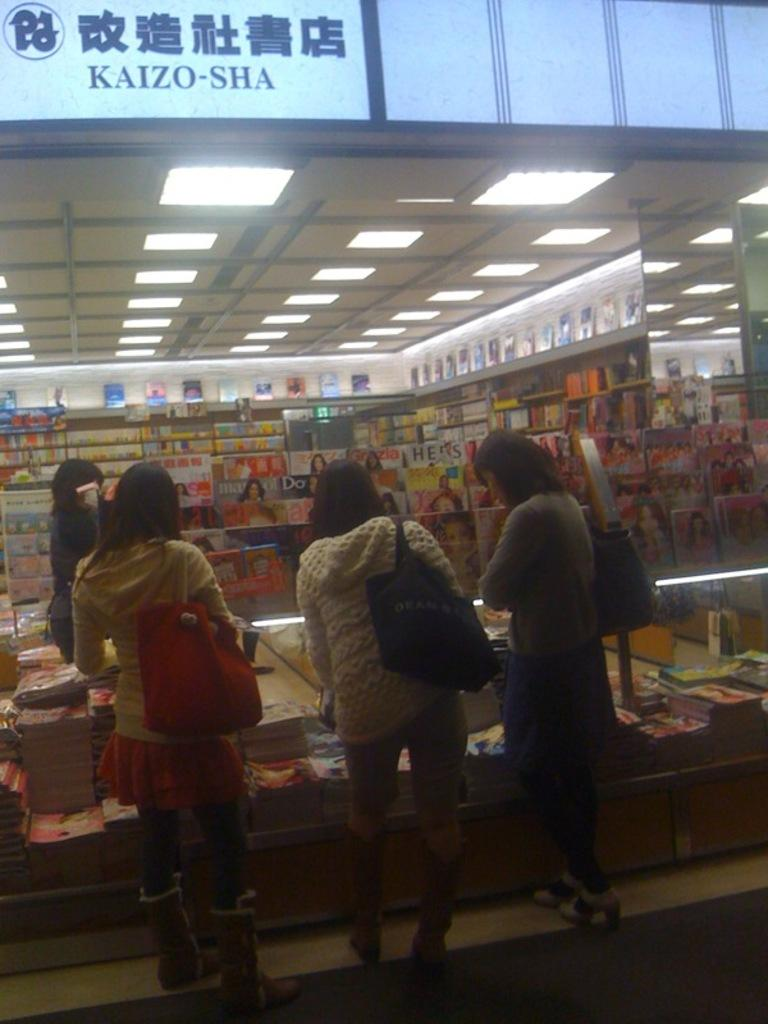<image>
Describe the image concisely. Three women are browsing magazines at the Kaizo-Sha bookstore. 